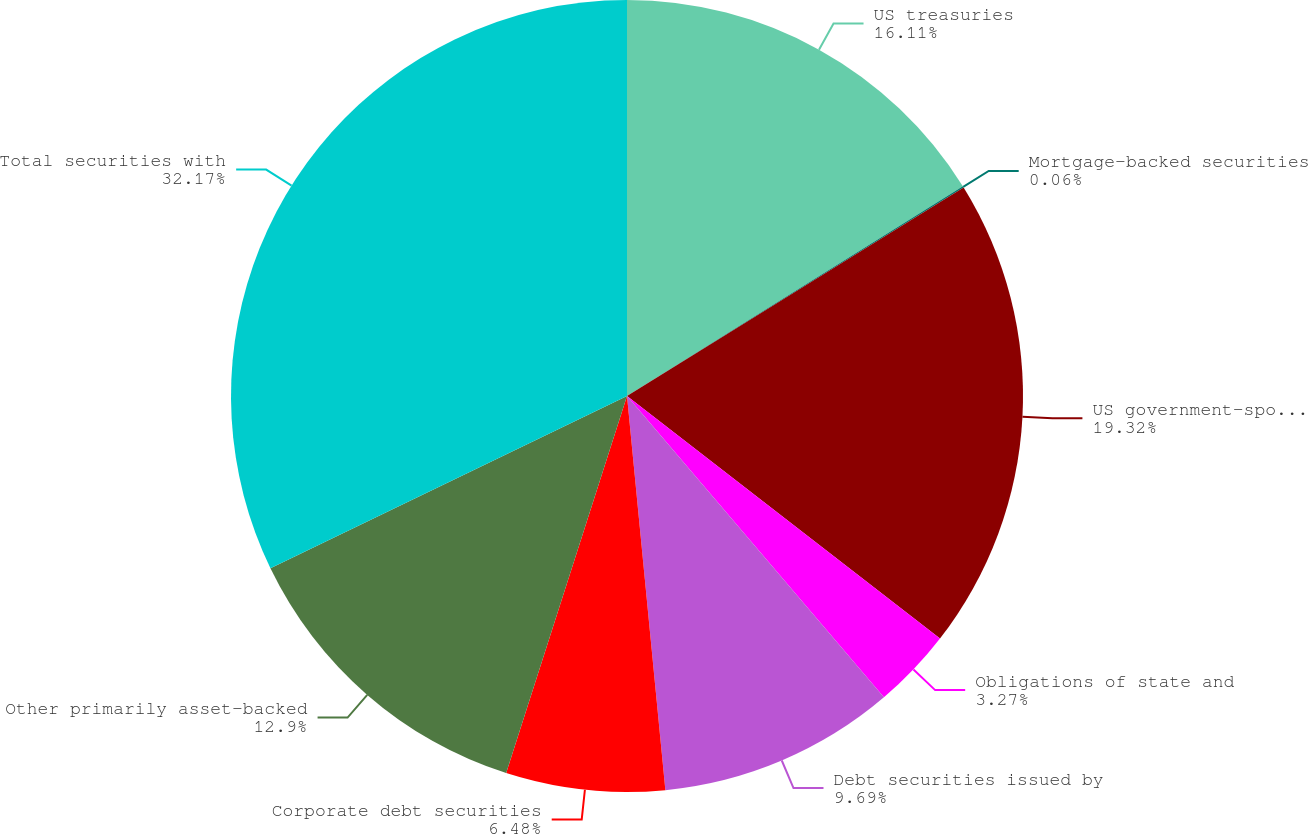Convert chart to OTSL. <chart><loc_0><loc_0><loc_500><loc_500><pie_chart><fcel>US treasuries<fcel>Mortgage-backed securities<fcel>US government-sponsored<fcel>Obligations of state and<fcel>Debt securities issued by<fcel>Corporate debt securities<fcel>Other primarily asset-backed<fcel>Total securities with<nl><fcel>16.11%<fcel>0.06%<fcel>19.32%<fcel>3.27%<fcel>9.69%<fcel>6.48%<fcel>12.9%<fcel>32.16%<nl></chart> 